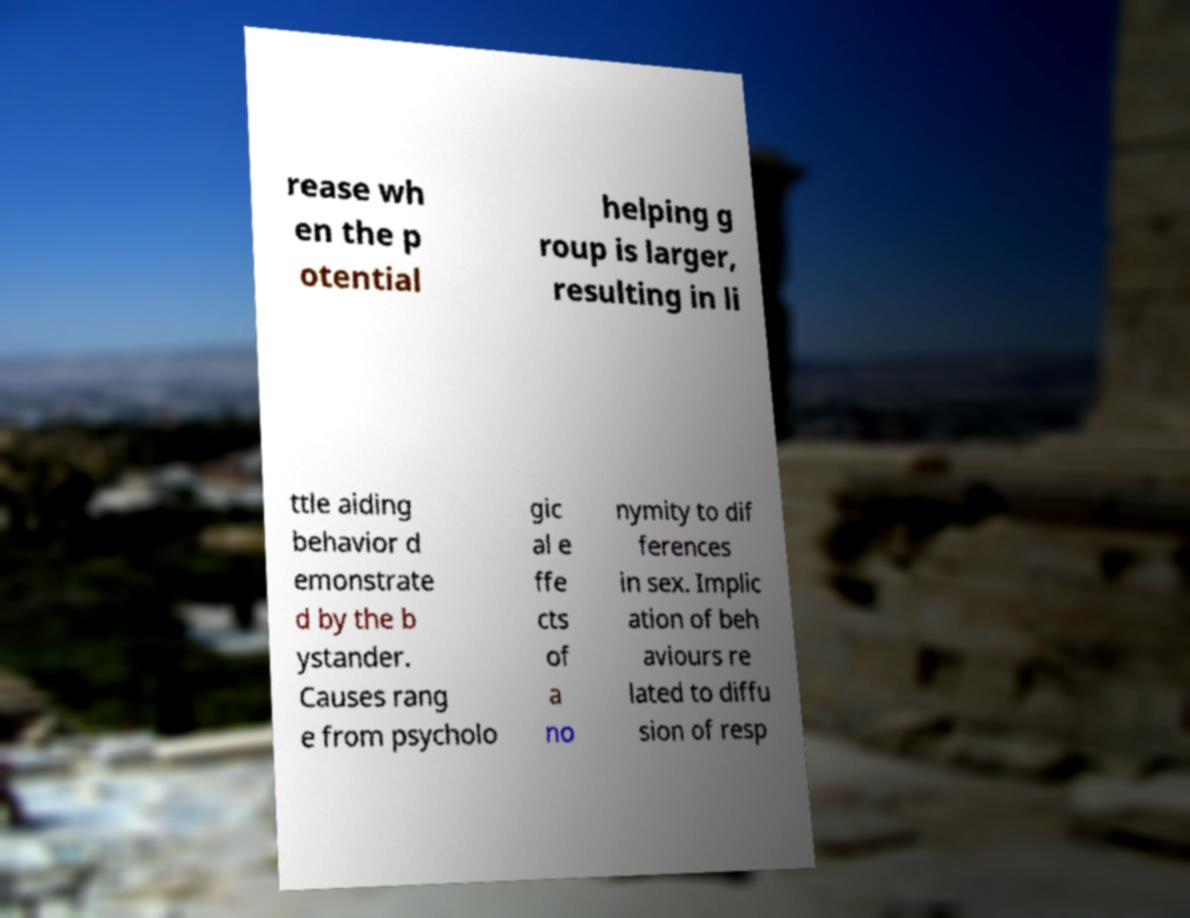What messages or text are displayed in this image? I need them in a readable, typed format. rease wh en the p otential helping g roup is larger, resulting in li ttle aiding behavior d emonstrate d by the b ystander. Causes rang e from psycholo gic al e ffe cts of a no nymity to dif ferences in sex. Implic ation of beh aviours re lated to diffu sion of resp 